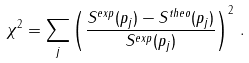<formula> <loc_0><loc_0><loc_500><loc_500>\chi ^ { 2 } = \sum _ { j } \left ( \frac { S ^ { e x p } ( p _ { j } ) - S ^ { t h e o } ( p _ { j } ) } { S ^ { e x p } ( p _ { j } ) } \right ) ^ { 2 } \, .</formula> 